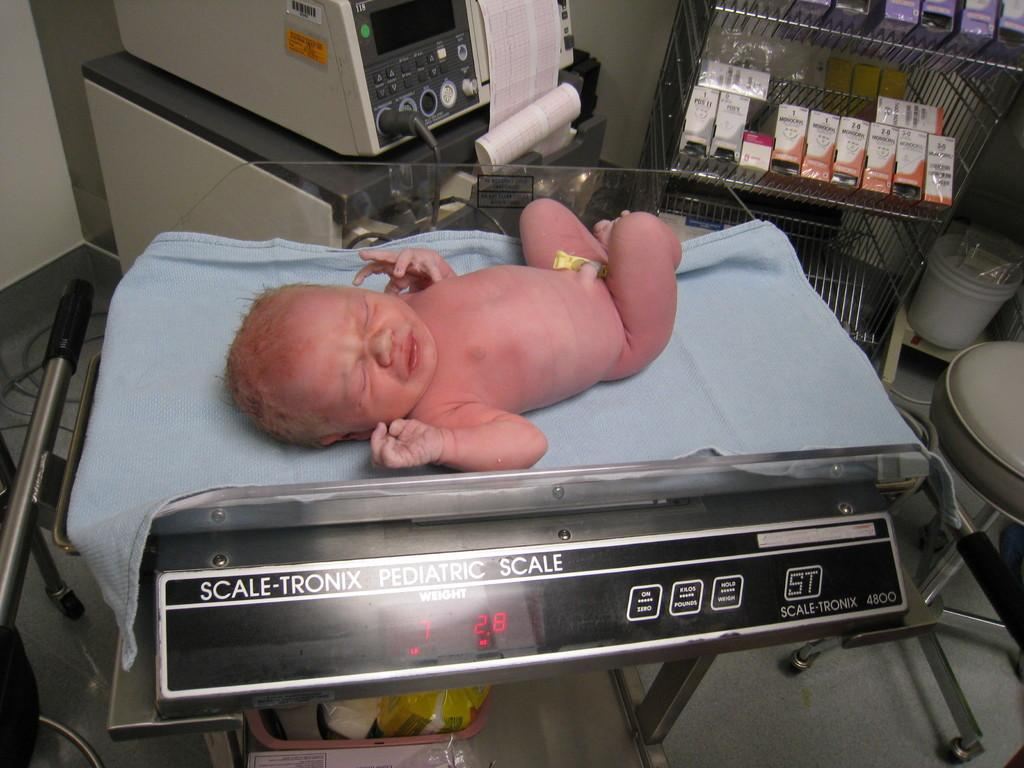What is the main subject of the image? There is a baby lying in the image. What other objects can be seen in the image? There is a weight machine, a paper, a box, a rack, a stool, and a dustbin in the image. What type of surface is visible in the image? There is a floor visible in the image. What type of creature is seen sliding on the sleet in the image? There is no creature or sleet present in the image. 